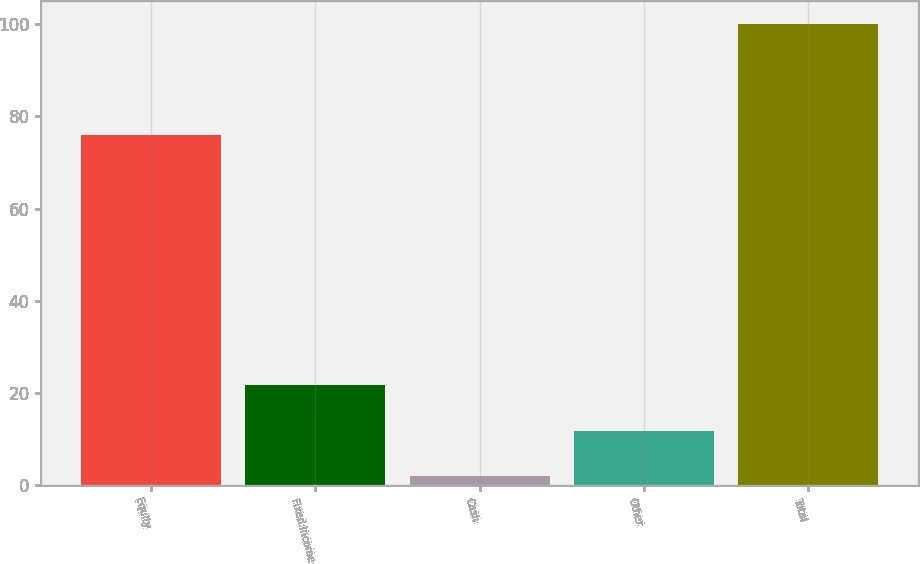Convert chart. <chart><loc_0><loc_0><loc_500><loc_500><bar_chart><fcel>Equity<fcel>Fixed Income<fcel>Cash<fcel>Other<fcel>Total<nl><fcel>76<fcel>21.6<fcel>2<fcel>11.8<fcel>100<nl></chart> 